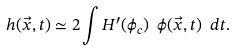Convert formula to latex. <formula><loc_0><loc_0><loc_500><loc_500>h ( \vec { x } , t ) \simeq 2 \int H ^ { \prime } ( \phi _ { c } ) \ \phi ( \vec { x } , t ) \ d t .</formula> 